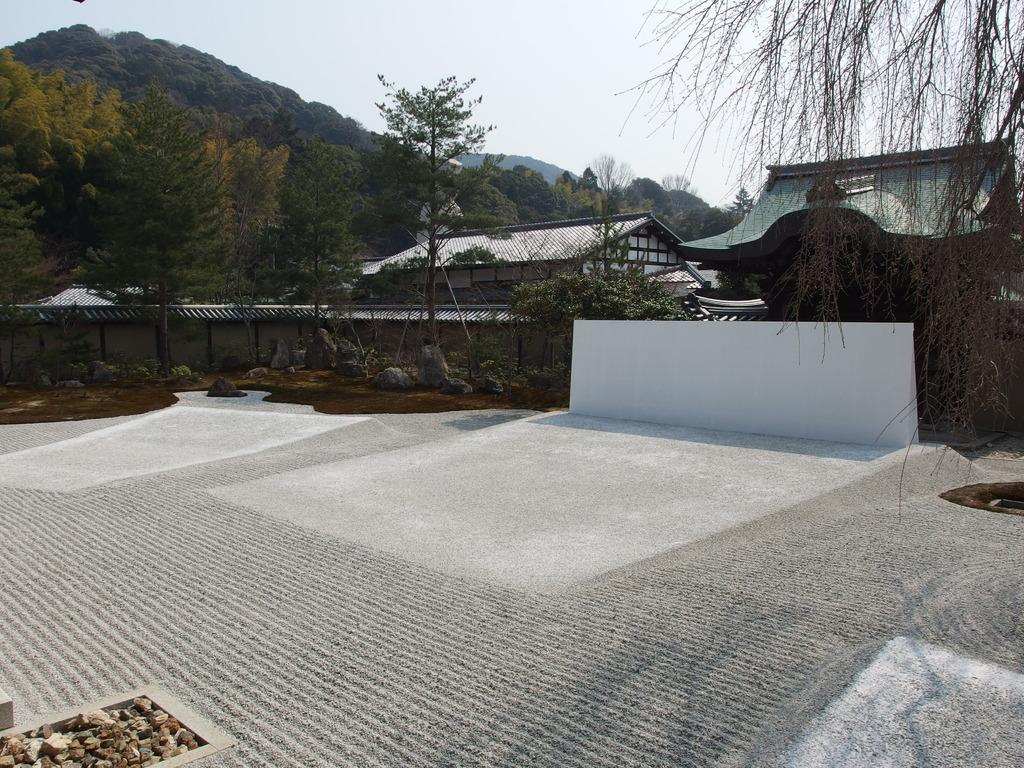What type of terrain is visible in the image? Ground is visible in the image. What type of structure is present in the image? There is a wall in the image. What type of material is present in the image? Stones are present in the image. What type of man-made structures can be seen in the image? There are buildings in the image. What type of vegetation is visible in the image? Trees are visible in the image. What type of natural landform is present in the image? Mountains are present in the image. What part of the natural environment is visible in the background of the image? The sky is visible in the background of the image. What shape is the destruction taking in the image? There is no destruction present in the image; it features a natural landscape with mountains, trees, and a sky. 